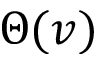Convert formula to latex. <formula><loc_0><loc_0><loc_500><loc_500>\Theta ( v )</formula> 